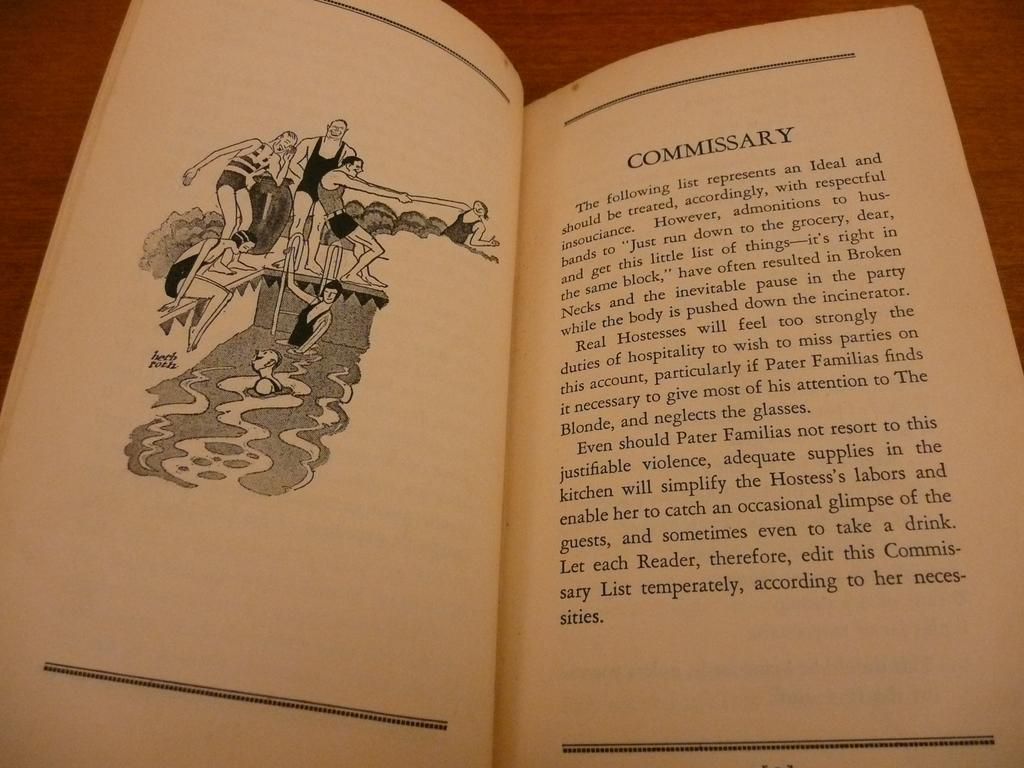Provide a one-sentence caption for the provided image. A passage in a book labeled "Commissary" is next to a black and white drawing of people at a swimming pool. 